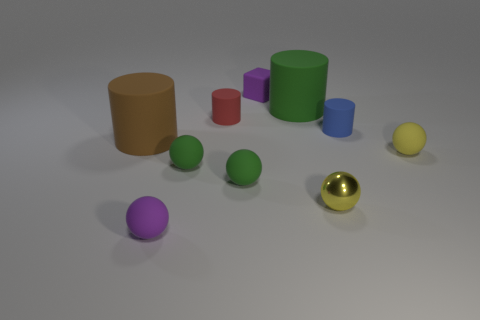Subtract all small yellow balls. How many balls are left? 3 Subtract all yellow cubes. How many green balls are left? 2 Subtract all green spheres. How many spheres are left? 3 Subtract all cylinders. How many objects are left? 6 Subtract 4 cylinders. How many cylinders are left? 0 Subtract all yellow blocks. Subtract all blue cylinders. How many blocks are left? 1 Subtract all purple rubber things. Subtract all brown cylinders. How many objects are left? 7 Add 8 tiny purple matte things. How many tiny purple matte things are left? 10 Add 1 tiny green things. How many tiny green things exist? 3 Subtract 1 purple blocks. How many objects are left? 9 